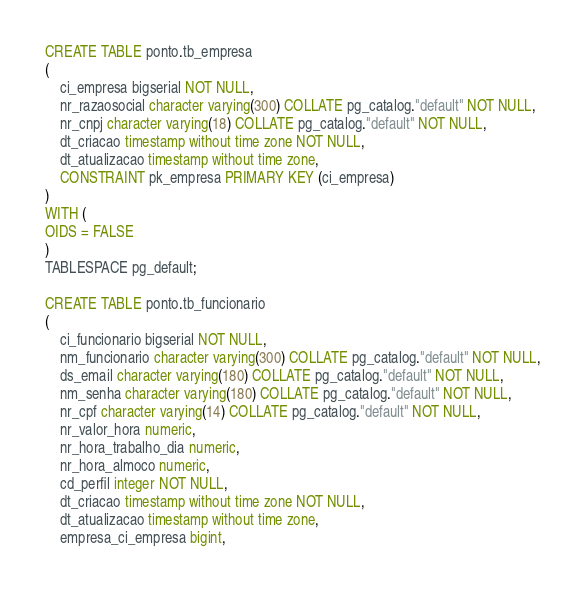Convert code to text. <code><loc_0><loc_0><loc_500><loc_500><_SQL_>CREATE TABLE ponto.tb_empresa
(
    ci_empresa bigserial NOT NULL,
    nr_razaosocial character varying(300) COLLATE pg_catalog."default" NOT NULL,
    nr_cnpj character varying(18) COLLATE pg_catalog."default" NOT NULL,
    dt_criacao timestamp without time zone NOT NULL,
    dt_atualizacao timestamp without time zone,
    CONSTRAINT pk_empresa PRIMARY KEY (ci_empresa)
)
WITH (
OIDS = FALSE
)
TABLESPACE pg_default;

CREATE TABLE ponto.tb_funcionario
(
    ci_funcionario bigserial NOT NULL,
    nm_funcionario character varying(300) COLLATE pg_catalog."default" NOT NULL,
    ds_email character varying(180) COLLATE pg_catalog."default" NOT NULL,
    nm_senha character varying(180) COLLATE pg_catalog."default" NOT NULL,
    nr_cpf character varying(14) COLLATE pg_catalog."default" NOT NULL,
    nr_valor_hora numeric,
    nr_hora_trabalho_dia numeric,
    nr_hora_almoco numeric,
    cd_perfil integer NOT NULL,
    dt_criacao timestamp without time zone NOT NULL,
    dt_atualizacao timestamp without time zone,
    empresa_ci_empresa bigint,</code> 